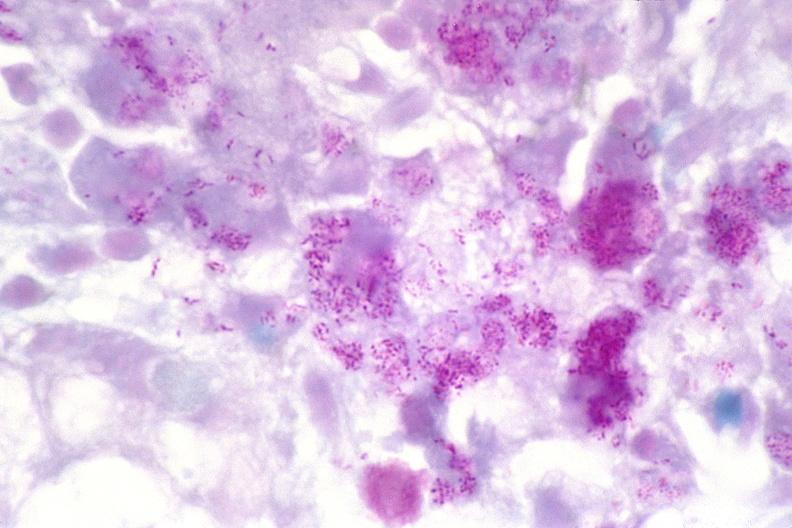do acid stain?
Answer the question using a single word or phrase. Yes 